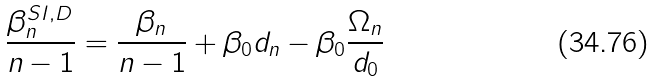Convert formula to latex. <formula><loc_0><loc_0><loc_500><loc_500>\frac { \beta _ { n } ^ { S I , D } } { n - 1 } = \frac { \beta _ { n } } { n - 1 } + \beta _ { 0 } d _ { n } - \beta _ { 0 } \frac { \Omega _ { n } } { d _ { 0 } }</formula> 